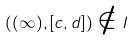Convert formula to latex. <formula><loc_0><loc_0><loc_500><loc_500>( ( \infty ) , [ c , d ] ) \notin I</formula> 